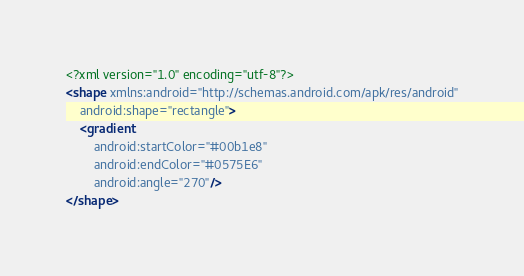<code> <loc_0><loc_0><loc_500><loc_500><_XML_><?xml version="1.0" encoding="utf-8"?>
<shape xmlns:android="http://schemas.android.com/apk/res/android"
    android:shape="rectangle">
    <gradient
        android:startColor="#00b1e8"
        android:endColor="#0575E6"
        android:angle="270"/>
</shape></code> 